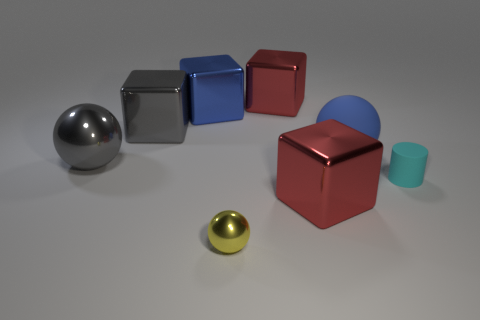What size is the matte thing that is the same shape as the yellow metal thing?
Offer a very short reply. Large. Is the number of blue objects to the left of the tiny metallic ball greater than the number of tiny cyan matte things to the right of the small cyan thing?
Give a very brief answer. Yes. Is the big blue sphere made of the same material as the red thing that is behind the gray shiny cube?
Provide a succinct answer. No. Is there any other thing that is the same shape as the tiny cyan object?
Keep it short and to the point. No. What is the color of the metallic thing that is both in front of the big matte ball and behind the cyan matte cylinder?
Ensure brevity in your answer.  Gray. What is the shape of the tiny matte thing that is right of the small ball?
Your answer should be compact. Cylinder. What is the size of the thing that is in front of the big red metallic object that is in front of the matte thing that is behind the small cyan object?
Keep it short and to the point. Small. How many large balls are right of the large ball left of the blue cube?
Provide a short and direct response. 1. What is the size of the metallic thing that is behind the tiny metallic thing and in front of the gray ball?
Give a very brief answer. Large. How many rubber objects are tiny cyan things or tiny balls?
Make the answer very short. 1. 